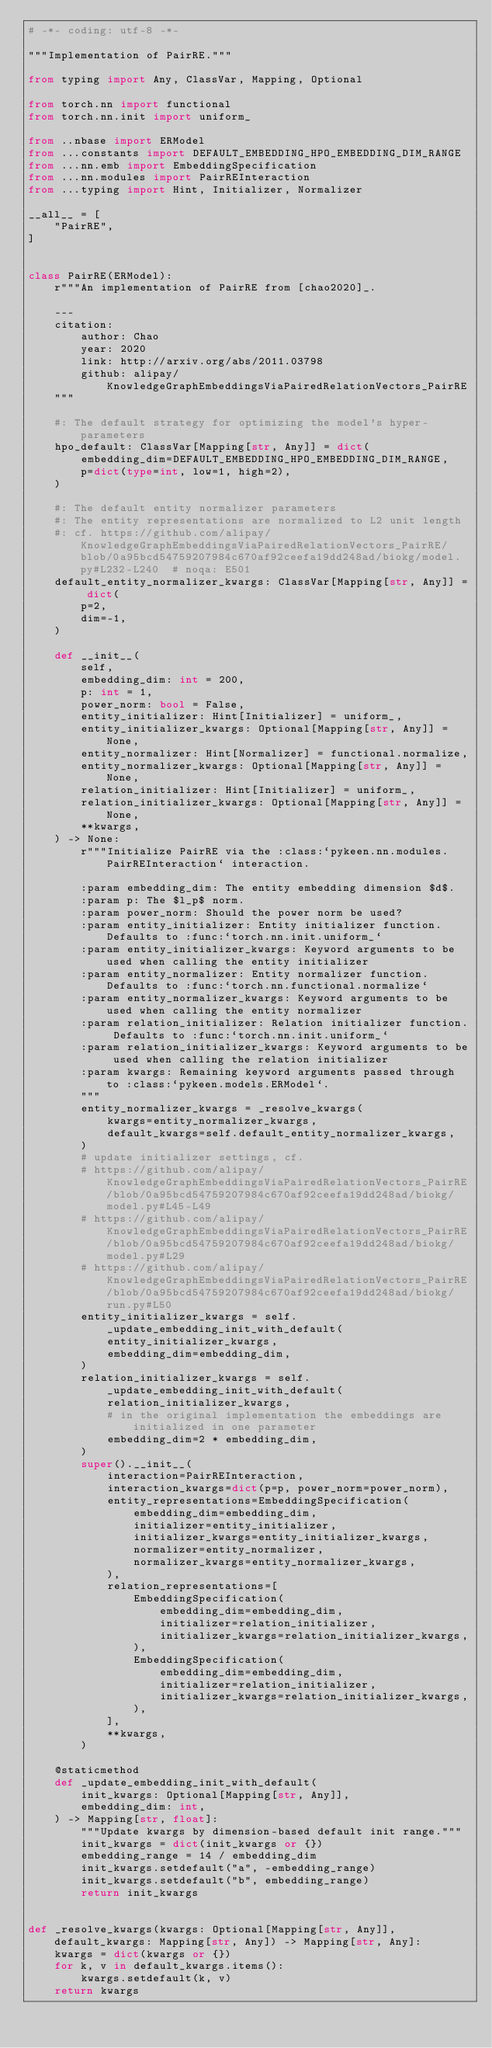Convert code to text. <code><loc_0><loc_0><loc_500><loc_500><_Python_># -*- coding: utf-8 -*-

"""Implementation of PairRE."""

from typing import Any, ClassVar, Mapping, Optional

from torch.nn import functional
from torch.nn.init import uniform_

from ..nbase import ERModel
from ...constants import DEFAULT_EMBEDDING_HPO_EMBEDDING_DIM_RANGE
from ...nn.emb import EmbeddingSpecification
from ...nn.modules import PairREInteraction
from ...typing import Hint, Initializer, Normalizer

__all__ = [
    "PairRE",
]


class PairRE(ERModel):
    r"""An implementation of PairRE from [chao2020]_.

    ---
    citation:
        author: Chao
        year: 2020
        link: http://arxiv.org/abs/2011.03798
        github: alipay/KnowledgeGraphEmbeddingsViaPairedRelationVectors_PairRE
    """

    #: The default strategy for optimizing the model's hyper-parameters
    hpo_default: ClassVar[Mapping[str, Any]] = dict(
        embedding_dim=DEFAULT_EMBEDDING_HPO_EMBEDDING_DIM_RANGE,
        p=dict(type=int, low=1, high=2),
    )

    #: The default entity normalizer parameters
    #: The entity representations are normalized to L2 unit length
    #: cf. https://github.com/alipay/KnowledgeGraphEmbeddingsViaPairedRelationVectors_PairRE/blob/0a95bcd54759207984c670af92ceefa19dd248ad/biokg/model.py#L232-L240  # noqa: E501
    default_entity_normalizer_kwargs: ClassVar[Mapping[str, Any]] = dict(
        p=2,
        dim=-1,
    )

    def __init__(
        self,
        embedding_dim: int = 200,
        p: int = 1,
        power_norm: bool = False,
        entity_initializer: Hint[Initializer] = uniform_,
        entity_initializer_kwargs: Optional[Mapping[str, Any]] = None,
        entity_normalizer: Hint[Normalizer] = functional.normalize,
        entity_normalizer_kwargs: Optional[Mapping[str, Any]] = None,
        relation_initializer: Hint[Initializer] = uniform_,
        relation_initializer_kwargs: Optional[Mapping[str, Any]] = None,
        **kwargs,
    ) -> None:
        r"""Initialize PairRE via the :class:`pykeen.nn.modules.PairREInteraction` interaction.

        :param embedding_dim: The entity embedding dimension $d$.
        :param p: The $l_p$ norm.
        :param power_norm: Should the power norm be used?
        :param entity_initializer: Entity initializer function. Defaults to :func:`torch.nn.init.uniform_`
        :param entity_initializer_kwargs: Keyword arguments to be used when calling the entity initializer
        :param entity_normalizer: Entity normalizer function. Defaults to :func:`torch.nn.functional.normalize`
        :param entity_normalizer_kwargs: Keyword arguments to be used when calling the entity normalizer
        :param relation_initializer: Relation initializer function. Defaults to :func:`torch.nn.init.uniform_`
        :param relation_initializer_kwargs: Keyword arguments to be used when calling the relation initializer
        :param kwargs: Remaining keyword arguments passed through to :class:`pykeen.models.ERModel`.
        """
        entity_normalizer_kwargs = _resolve_kwargs(
            kwargs=entity_normalizer_kwargs,
            default_kwargs=self.default_entity_normalizer_kwargs,
        )
        # update initializer settings, cf.
        # https://github.com/alipay/KnowledgeGraphEmbeddingsViaPairedRelationVectors_PairRE/blob/0a95bcd54759207984c670af92ceefa19dd248ad/biokg/model.py#L45-L49
        # https://github.com/alipay/KnowledgeGraphEmbeddingsViaPairedRelationVectors_PairRE/blob/0a95bcd54759207984c670af92ceefa19dd248ad/biokg/model.py#L29
        # https://github.com/alipay/KnowledgeGraphEmbeddingsViaPairedRelationVectors_PairRE/blob/0a95bcd54759207984c670af92ceefa19dd248ad/biokg/run.py#L50
        entity_initializer_kwargs = self._update_embedding_init_with_default(
            entity_initializer_kwargs,
            embedding_dim=embedding_dim,
        )
        relation_initializer_kwargs = self._update_embedding_init_with_default(
            relation_initializer_kwargs,
            # in the original implementation the embeddings are initialized in one parameter
            embedding_dim=2 * embedding_dim,
        )
        super().__init__(
            interaction=PairREInteraction,
            interaction_kwargs=dict(p=p, power_norm=power_norm),
            entity_representations=EmbeddingSpecification(
                embedding_dim=embedding_dim,
                initializer=entity_initializer,
                initializer_kwargs=entity_initializer_kwargs,
                normalizer=entity_normalizer,
                normalizer_kwargs=entity_normalizer_kwargs,
            ),
            relation_representations=[
                EmbeddingSpecification(
                    embedding_dim=embedding_dim,
                    initializer=relation_initializer,
                    initializer_kwargs=relation_initializer_kwargs,
                ),
                EmbeddingSpecification(
                    embedding_dim=embedding_dim,
                    initializer=relation_initializer,
                    initializer_kwargs=relation_initializer_kwargs,
                ),
            ],
            **kwargs,
        )

    @staticmethod
    def _update_embedding_init_with_default(
        init_kwargs: Optional[Mapping[str, Any]],
        embedding_dim: int,
    ) -> Mapping[str, float]:
        """Update kwargs by dimension-based default init range."""
        init_kwargs = dict(init_kwargs or {})
        embedding_range = 14 / embedding_dim
        init_kwargs.setdefault("a", -embedding_range)
        init_kwargs.setdefault("b", embedding_range)
        return init_kwargs


def _resolve_kwargs(kwargs: Optional[Mapping[str, Any]], default_kwargs: Mapping[str, Any]) -> Mapping[str, Any]:
    kwargs = dict(kwargs or {})
    for k, v in default_kwargs.items():
        kwargs.setdefault(k, v)
    return kwargs
</code> 